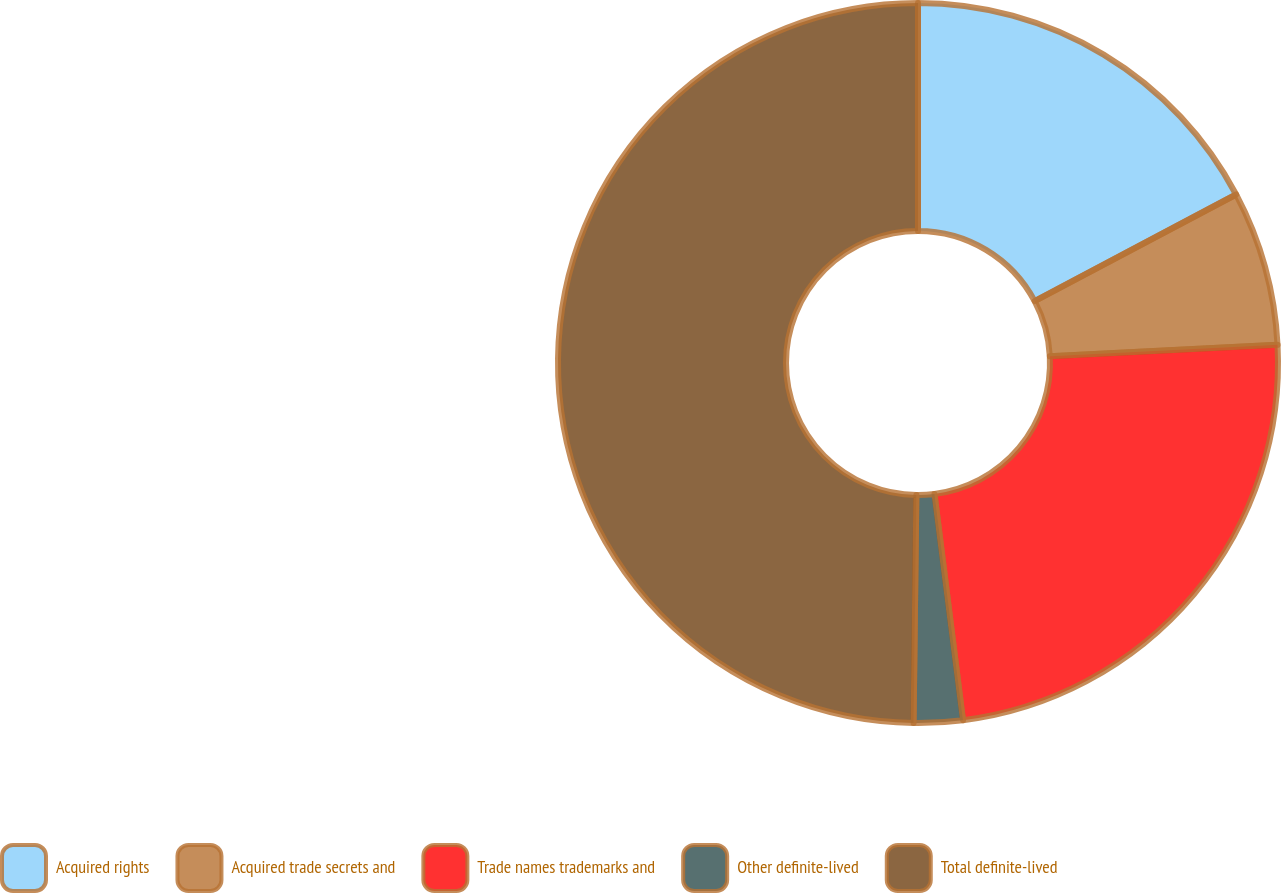<chart> <loc_0><loc_0><loc_500><loc_500><pie_chart><fcel>Acquired rights<fcel>Acquired trade secrets and<fcel>Trade names trademarks and<fcel>Other definite-lived<fcel>Total definite-lived<nl><fcel>17.25%<fcel>6.95%<fcel>23.81%<fcel>2.19%<fcel>49.81%<nl></chart> 